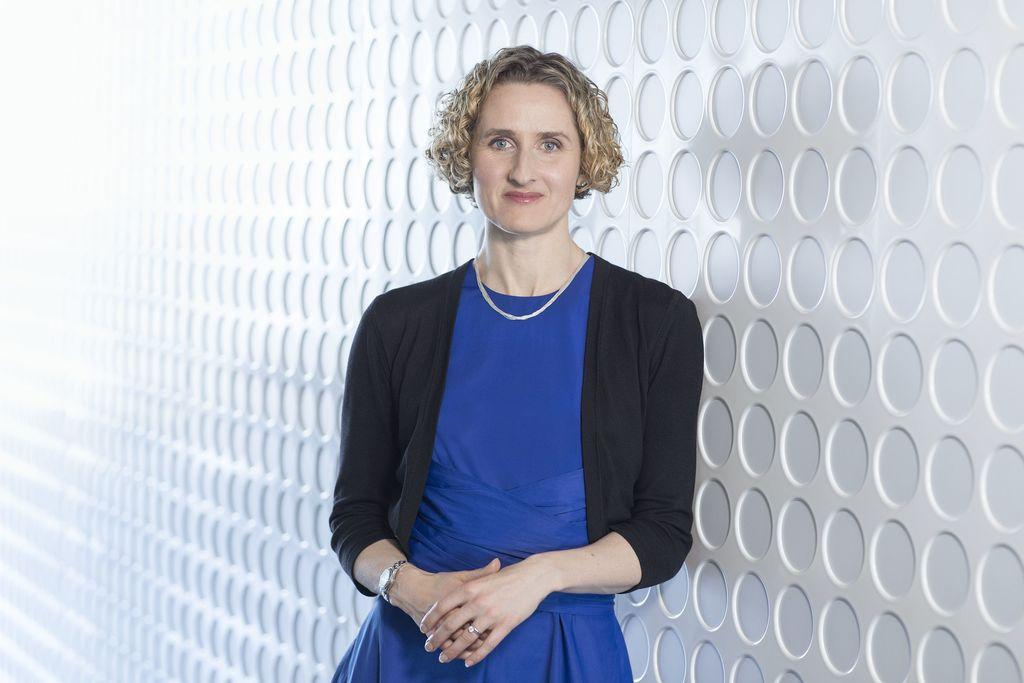What color is the dress that the woman is wearing in the image? The woman is wearing a blue dress in the image. What type of outerwear is the woman wearing? The woman is wearing a black jacket in the image. What direction is the woman looking in the image? The woman is looking forward in the image. What color is the background of the image? The background of the image is white. What type of plants can be seen in the image? There are no plants visible in the image; it features a woman wearing a blue dress and a black jacket, with a white background. 